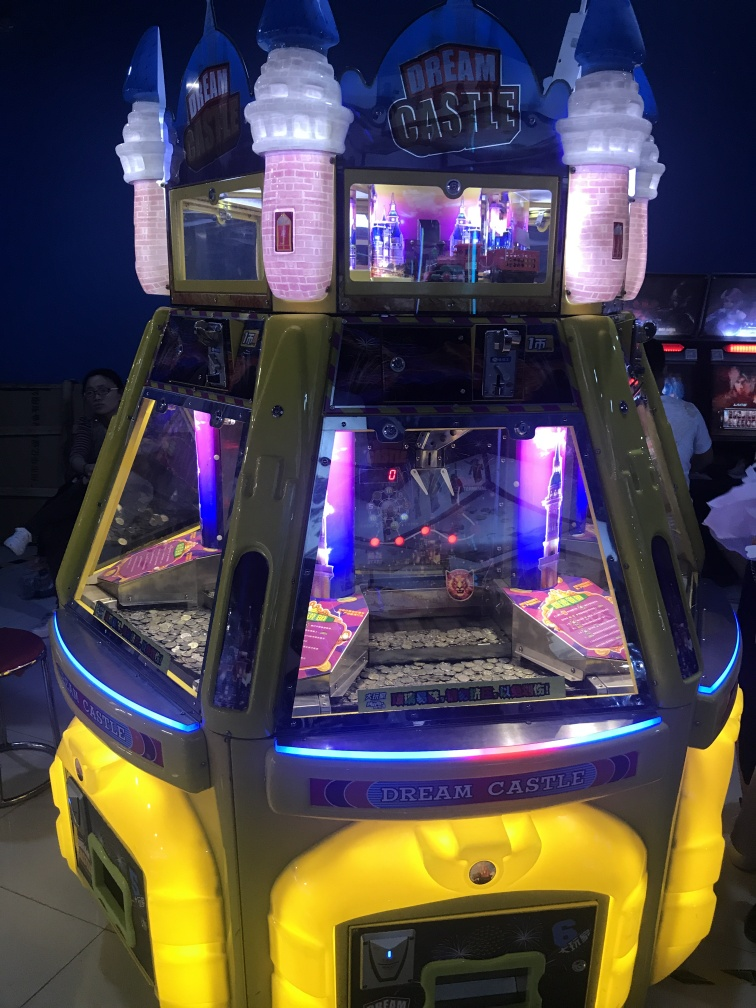What can be said about the composition of the image?
A. Poor
B. Lackluster
C. Good
Answer with the option's letter from the given choices directly. C. The image shows a coin-operated arcade game called 'Dream Castle', which is colorfully lit and appears visually appealing with its bright colors and playful design. The composition is engaging as it effectively captures the vibrancy and allure of the arcade game, drawing viewers' interest with its promise of fun and entertainment. 